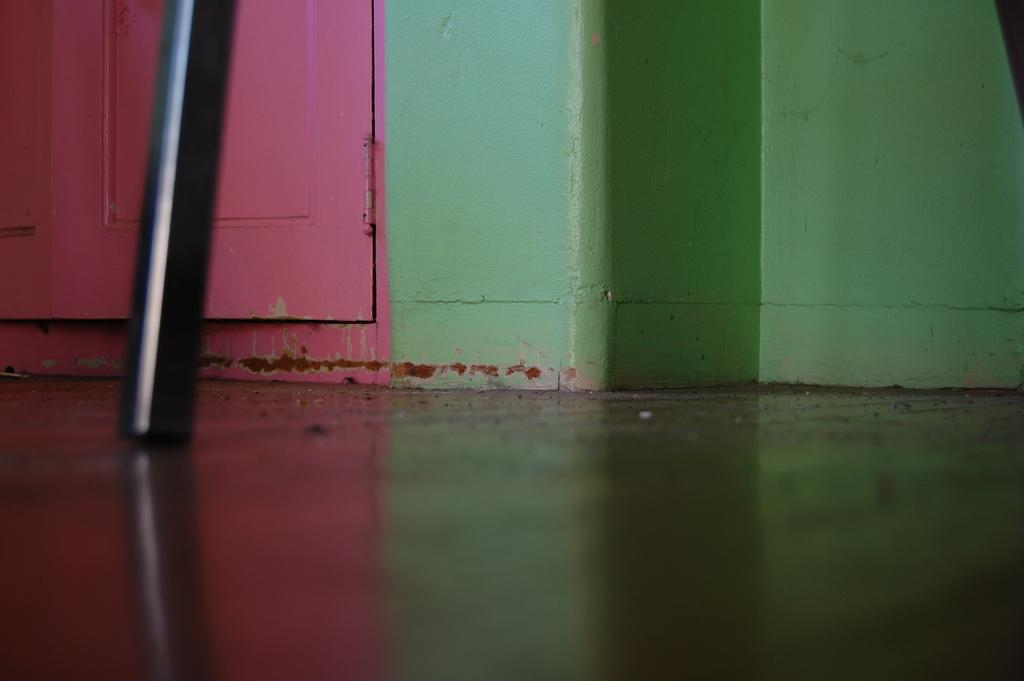What color is the wall in the image? The wall in the image is green. Where are the doors located in the image? The doors are on the left side of the image. What color are the doors? The doors are pink in color. What shape is the ghost in the image? There is no ghost present in the image. What type of blade is used to cut the green wall in the image? There is no blade or cutting involved in the image; it is a static representation of a wall and doors. 